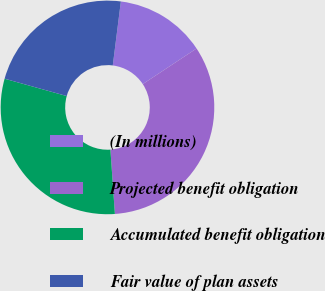<chart> <loc_0><loc_0><loc_500><loc_500><pie_chart><fcel>(In millions)<fcel>Projected benefit obligation<fcel>Accumulated benefit obligation<fcel>Fair value of plan assets<nl><fcel>13.7%<fcel>33.2%<fcel>30.44%<fcel>22.67%<nl></chart> 